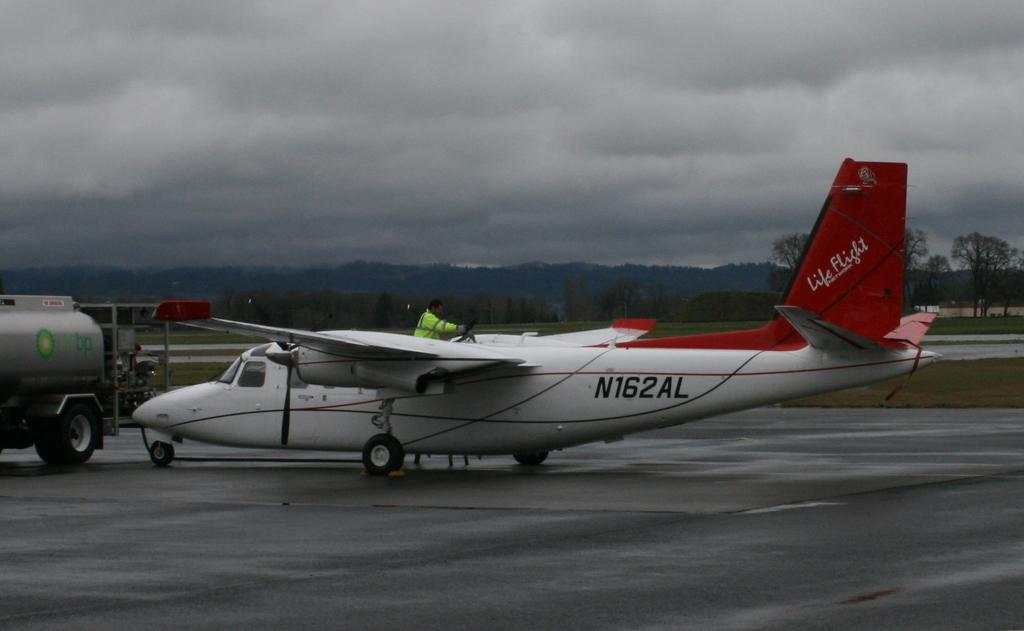<image>
Share a concise interpretation of the image provided. A Life Flight aircraft sits on a wet runway under a cloudy sky. 